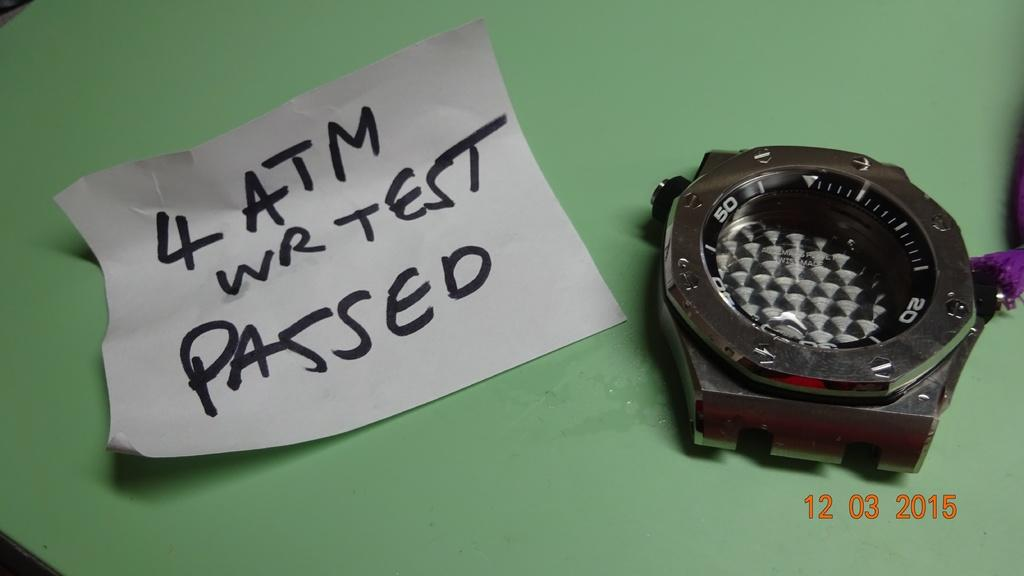<image>
Present a compact description of the photo's key features. A watch sits next to a note with "4 ATM" written on it. 